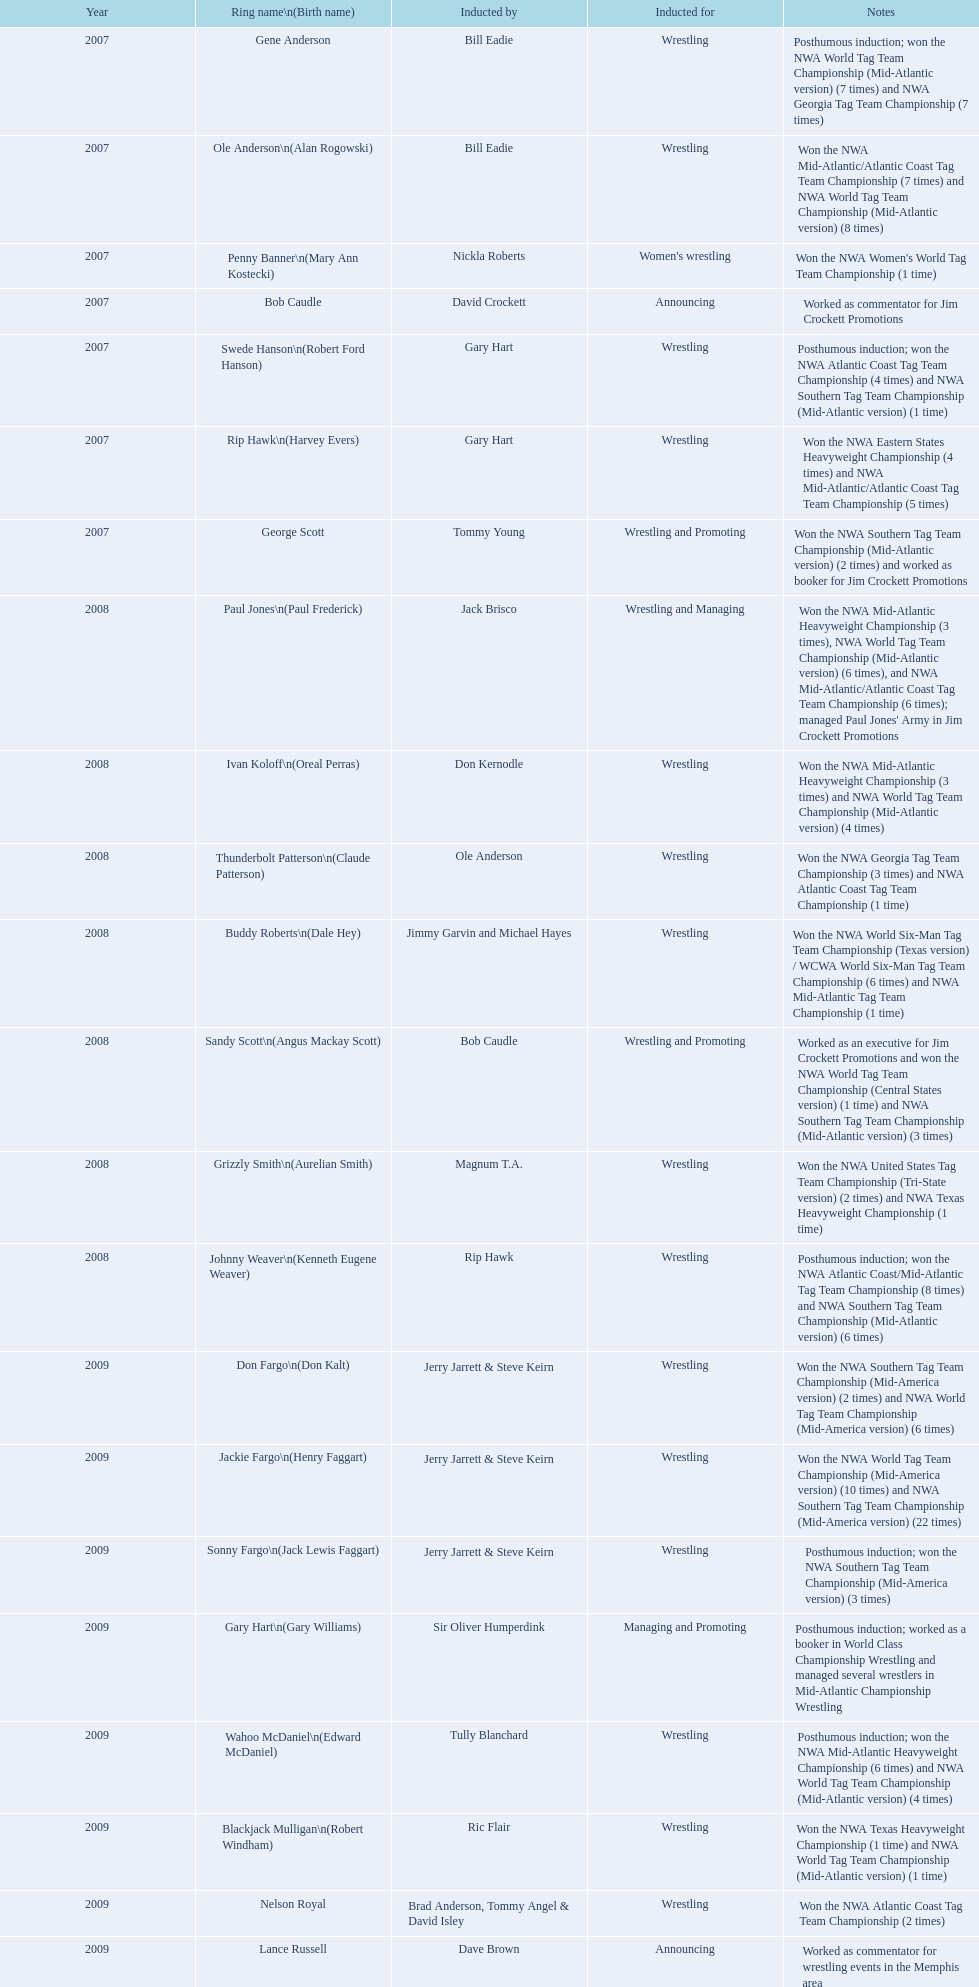In which year was the initiation conducted? 2007. Which inductee was not living? Gene Anderson. 